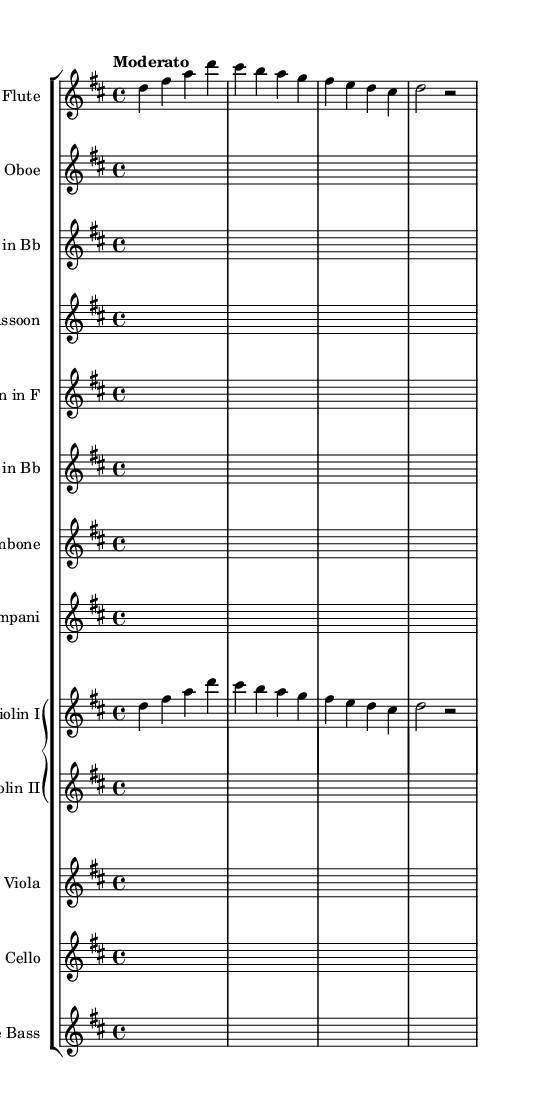What is the key signature of this music? The key signature is D major, which has two sharps (F# and C#). This can be determined by looking at the key signature symbol at the beginning of the staff, which indicates the sharps present in the scale.
Answer: D major What is the time signature of this music? The time signature is 4/4, which is indicated at the beginning of the score. This means there are four beats in each measure, and the quarter note gets one beat.
Answer: 4/4 What is the tempo marking of this piece? The tempo marking is "Moderato," which suggests a moderate pace of around 108-120 beats per minute. This is noted above the staff, indicating the intended speed of the piece.
Answer: Moderato How many measures are in the provided music? There are four measures in the provided music excerpt. This can be counted by examining the vertical lines (bar lines) that separate each measure in the staff.
Answer: 4 Which instruments are included in this orchestration? The instruments included are Flute, Oboe, Clarinet in Bb, Bassoon, Horn in F, Trumpet in Bb, Trombone, Timpani, Violin I, Violin II, Viola, Cello, and Double Bass. This can be found in the score headings listing each instrument before the music staff.
Answer: Flute, Oboe, Clarinet in Bb, Bassoon, Horn in F, Trumpet in Bb, Trombone, Timpani, Violin I, Violin II, Viola, Cello, Double Bass What is the main theme of the Symphony indicated by the violin part? The main theme is a melodic phrase starting on D, which can be inferred from the notes written in the Violin I part. The sequence of notes gives a characteristic melodic motif that serves as the main theme.
Answer: D, F#, A, D, C#, B, A, G 